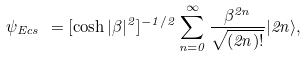Convert formula to latex. <formula><loc_0><loc_0><loc_500><loc_500>\psi _ { E c s } \ = [ \cosh { | \beta | ^ { 2 } } ] ^ { - 1 / 2 } \sum _ { n = 0 } ^ { \infty } \frac { \beta ^ { 2 n } } { \sqrt { ( 2 n ) ! } } | 2 n \rangle ,</formula> 